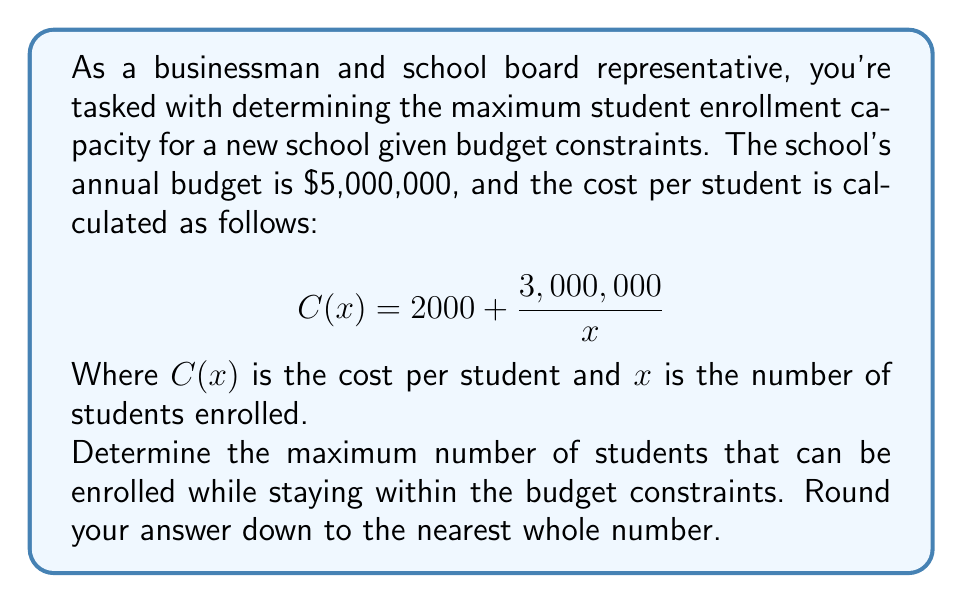Provide a solution to this math problem. To solve this problem, we'll follow these steps:

1) First, we need to set up an inequality that represents our budget constraint:

   $x \cdot C(x) \leq 5,000,000$

2) Substitute the given cost function:

   $x \cdot (2000 + \frac{3,000,000}{x}) \leq 5,000,000$

3) Expand the left side of the inequality:

   $2000x + 3,000,000 \leq 5,000,000$

4) Subtract 3,000,000 from both sides:

   $2000x \leq 2,000,000$

5) Divide both sides by 2000:

   $x \leq 1000$

6) Since we're looking for the maximum enrollment and we need to round down to the nearest whole number, our answer is 1000 students.

To verify, let's check the cost for 1000 students:

$C(1000) = 2000 + \frac{3,000,000}{1000} = 5000$

Total cost: $1000 \cdot 5000 = 5,000,000$

This confirms that 1000 students is the maximum enrollment within the budget.
Answer: 1000 students 